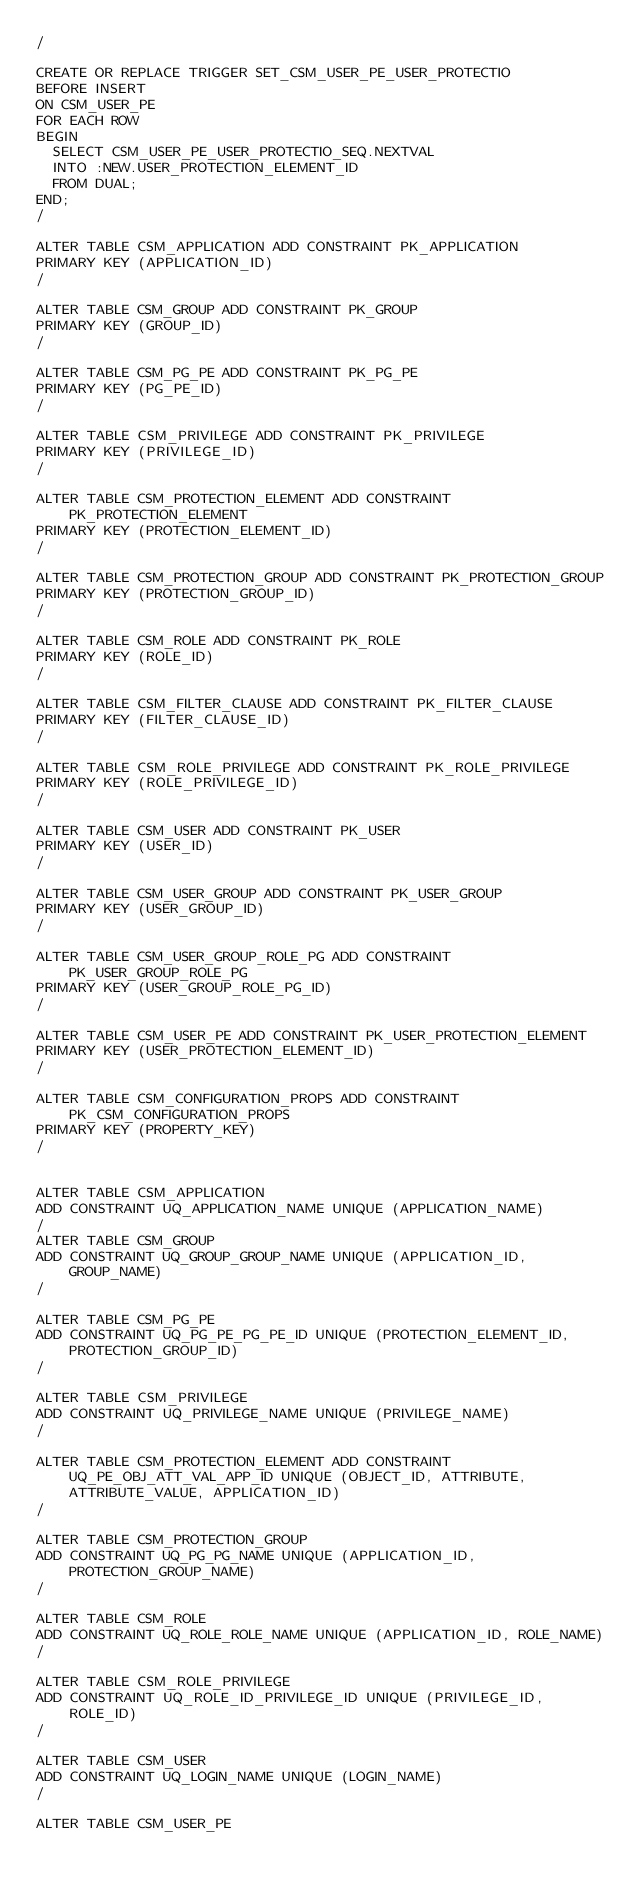Convert code to text. <code><loc_0><loc_0><loc_500><loc_500><_SQL_>/

CREATE OR REPLACE TRIGGER SET_CSM_USER_PE_USER_PROTECTIO
BEFORE INSERT
ON CSM_USER_PE
FOR EACH ROW
BEGIN
  SELECT CSM_USER_PE_USER_PROTECTIO_SEQ.NEXTVAL
  INTO :NEW.USER_PROTECTION_ELEMENT_ID
  FROM DUAL;
END;
/

ALTER TABLE CSM_APPLICATION ADD CONSTRAINT PK_APPLICATION 
PRIMARY KEY (APPLICATION_ID) 
/

ALTER TABLE CSM_GROUP ADD CONSTRAINT PK_GROUP 
PRIMARY KEY (GROUP_ID) 
/

ALTER TABLE CSM_PG_PE ADD CONSTRAINT PK_PG_PE 
PRIMARY KEY (PG_PE_ID) 
/

ALTER TABLE CSM_PRIVILEGE ADD CONSTRAINT PK_PRIVILEGE 
PRIMARY KEY (PRIVILEGE_ID) 
/

ALTER TABLE CSM_PROTECTION_ELEMENT ADD CONSTRAINT PK_PROTECTION_ELEMENT 
PRIMARY KEY (PROTECTION_ELEMENT_ID) 
/

ALTER TABLE CSM_PROTECTION_GROUP ADD CONSTRAINT PK_PROTECTION_GROUP 
PRIMARY KEY (PROTECTION_GROUP_ID) 
/

ALTER TABLE CSM_ROLE ADD CONSTRAINT PK_ROLE 
PRIMARY KEY (ROLE_ID) 
/

ALTER TABLE CSM_FILTER_CLAUSE ADD CONSTRAINT PK_FILTER_CLAUSE 
PRIMARY KEY (FILTER_CLAUSE_ID) 
/

ALTER TABLE CSM_ROLE_PRIVILEGE ADD CONSTRAINT PK_ROLE_PRIVILEGE 
PRIMARY KEY (ROLE_PRIVILEGE_ID) 
/

ALTER TABLE CSM_USER ADD CONSTRAINT PK_USER 
PRIMARY KEY (USER_ID) 
/

ALTER TABLE CSM_USER_GROUP ADD CONSTRAINT PK_USER_GROUP 
PRIMARY KEY (USER_GROUP_ID) 
/

ALTER TABLE CSM_USER_GROUP_ROLE_PG ADD CONSTRAINT PK_USER_GROUP_ROLE_PG 
PRIMARY KEY (USER_GROUP_ROLE_PG_ID) 
/

ALTER TABLE CSM_USER_PE ADD CONSTRAINT PK_USER_PROTECTION_ELEMENT 
PRIMARY KEY (USER_PROTECTION_ELEMENT_ID) 
/

ALTER TABLE CSM_CONFIGURATION_PROPS ADD CONSTRAINT PK_CSM_CONFIGURATION_PROPS
PRIMARY KEY (PROPERTY_KEY) 
/


ALTER TABLE CSM_APPLICATION
ADD CONSTRAINT UQ_APPLICATION_NAME UNIQUE (APPLICATION_NAME)
/
ALTER TABLE CSM_GROUP
ADD CONSTRAINT UQ_GROUP_GROUP_NAME UNIQUE (APPLICATION_ID, GROUP_NAME)
/

ALTER TABLE CSM_PG_PE
ADD CONSTRAINT UQ_PG_PE_PG_PE_ID UNIQUE (PROTECTION_ELEMENT_ID, PROTECTION_GROUP_ID)
/

ALTER TABLE CSM_PRIVILEGE
ADD CONSTRAINT UQ_PRIVILEGE_NAME UNIQUE (PRIVILEGE_NAME)
/

ALTER TABLE CSM_PROTECTION_ELEMENT ADD CONSTRAINT UQ_PE_OBJ_ATT_VAL_APP_ID UNIQUE (OBJECT_ID, ATTRIBUTE, ATTRIBUTE_VALUE, APPLICATION_ID)
/

ALTER TABLE CSM_PROTECTION_GROUP
ADD CONSTRAINT UQ_PG_PG_NAME UNIQUE (APPLICATION_ID, PROTECTION_GROUP_NAME)
/

ALTER TABLE CSM_ROLE
ADD CONSTRAINT UQ_ROLE_ROLE_NAME UNIQUE (APPLICATION_ID, ROLE_NAME)
/

ALTER TABLE CSM_ROLE_PRIVILEGE
ADD CONSTRAINT UQ_ROLE_ID_PRIVILEGE_ID UNIQUE (PRIVILEGE_ID, ROLE_ID)
/

ALTER TABLE CSM_USER
ADD CONSTRAINT UQ_LOGIN_NAME UNIQUE (LOGIN_NAME)
/

ALTER TABLE CSM_USER_PE</code> 